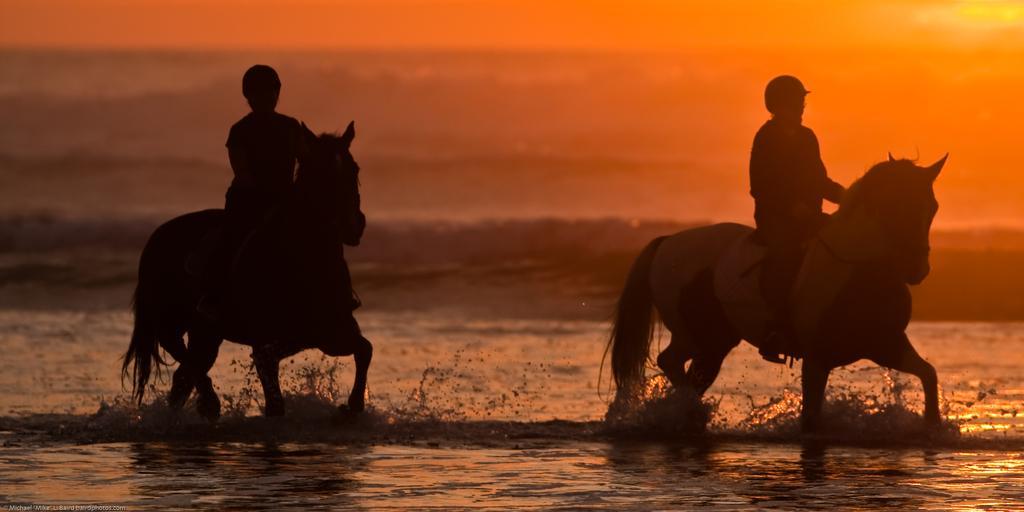Could you give a brief overview of what you see in this image? It is a black and white image in which there are two horses ridden by the two men. At the top there is a sunset. 